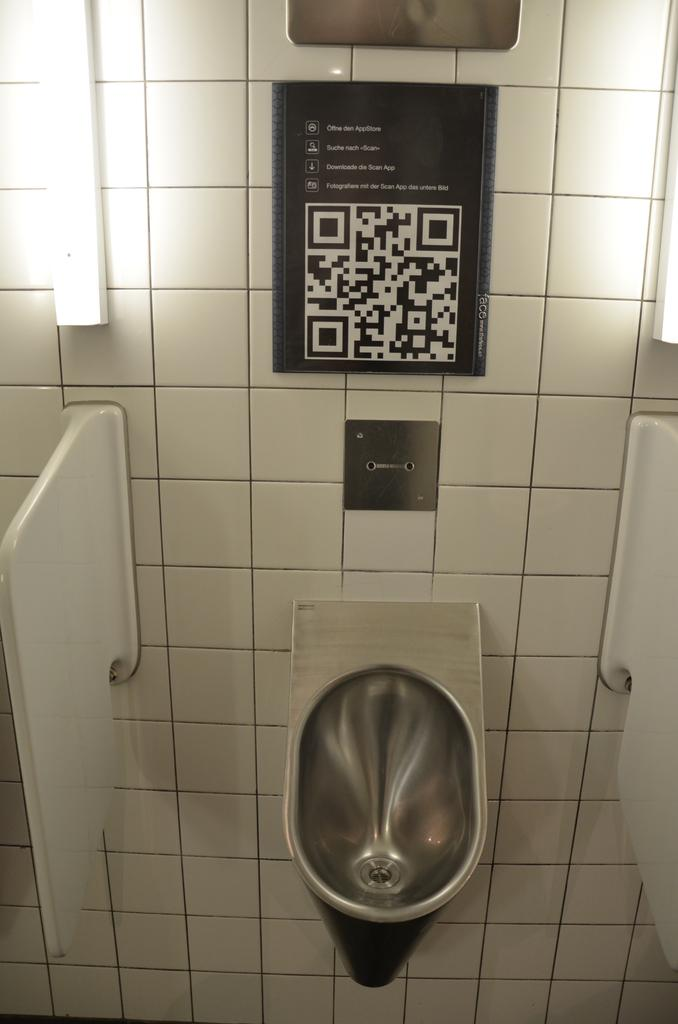What type of fixture is present in the image? There is a toilet sink in the image. What color is the prominent object in the image? There is a white color object in the image. What is used for illumination in the image? There is a light in the image. What type of material is covering the wall in the image? There are boards on the wall in the image. What type of shoe is hanging on the wall in the image? There is no shoe present in the image; it features a toilet sink, a white object, a light, and boards on the wall. What type of brush is used for cleaning the light in the image? There is no brush present in the image, and the purpose of the light is not mentioned, so it cannot be determined if a brush is used for cleaning it. 